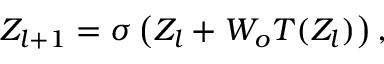<formula> <loc_0><loc_0><loc_500><loc_500>Z _ { l + 1 } = \sigma \left ( Z _ { l } + W _ { o } T ( Z _ { l } ) \right ) ,</formula> 